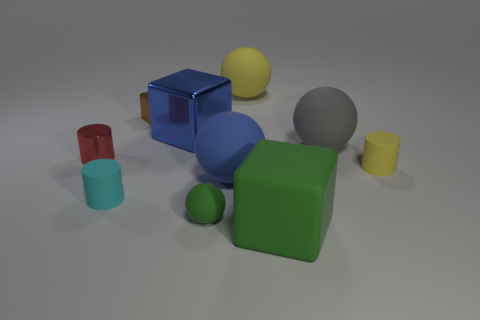What is the size of the matte cylinder that is behind the tiny rubber cylinder that is in front of the tiny yellow cylinder?
Keep it short and to the point. Small. Are there any purple rubber cylinders that have the same size as the blue matte ball?
Provide a succinct answer. No. There is a cube that is the same material as the yellow ball; what color is it?
Offer a very short reply. Green. Are there fewer tiny metallic blocks than green things?
Keep it short and to the point. Yes. What is the big sphere that is both right of the large blue ball and in front of the large blue shiny object made of?
Offer a very short reply. Rubber. Are there any yellow objects that are in front of the cylinder that is behind the tiny yellow thing?
Provide a succinct answer. Yes. How many objects are the same color as the matte block?
Your response must be concise. 1. What is the material of the other big thing that is the same color as the big shiny object?
Provide a succinct answer. Rubber. Are the cyan cylinder and the small red cylinder made of the same material?
Your answer should be very brief. No. Are there any large shiny blocks in front of the large green object?
Offer a very short reply. No. 